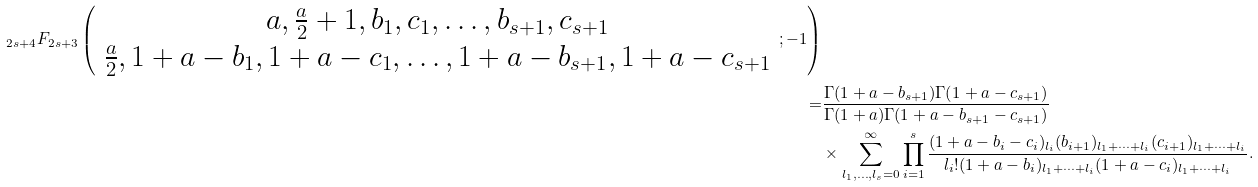<formula> <loc_0><loc_0><loc_500><loc_500>_ { 2 s + 4 } F _ { 2 s + 3 } \left ( \begin{array} { c } a , \frac { a } { 2 } + 1 , b _ { 1 } , c _ { 1 } , \dots , b _ { s + 1 } , c _ { s + 1 } \\ \frac { a } { 2 } , 1 + a - b _ { 1 } , 1 + a - c _ { 1 } , \dots , 1 + a - b _ { s + 1 } , 1 + a - c _ { s + 1 } \end{array} ; - 1 \right ) \\ = & \frac { \Gamma ( 1 + a - b _ { s + 1 } ) \Gamma ( 1 + a - c _ { s + 1 } ) } { \Gamma ( 1 + a ) \Gamma ( 1 + a - b _ { s + 1 } - c _ { s + 1 } ) } \\ & \times \sum _ { l _ { 1 } , \dots , l _ { s } = 0 } ^ { \infty } \prod _ { i = 1 } ^ { s } \frac { ( 1 + a - b _ { i } - c _ { i } ) _ { l _ { i } } ( b _ { i + 1 } ) _ { l _ { 1 } + \cdots + l _ { i } } ( c _ { i + 1 } ) _ { l _ { 1 } + \cdots + l _ { i } } } { l _ { i } ! ( 1 + a - b _ { i } ) _ { l _ { 1 } + \cdots + l _ { i } } ( 1 + a - c _ { i } ) _ { l _ { 1 } + \cdots + l _ { i } } } .</formula> 